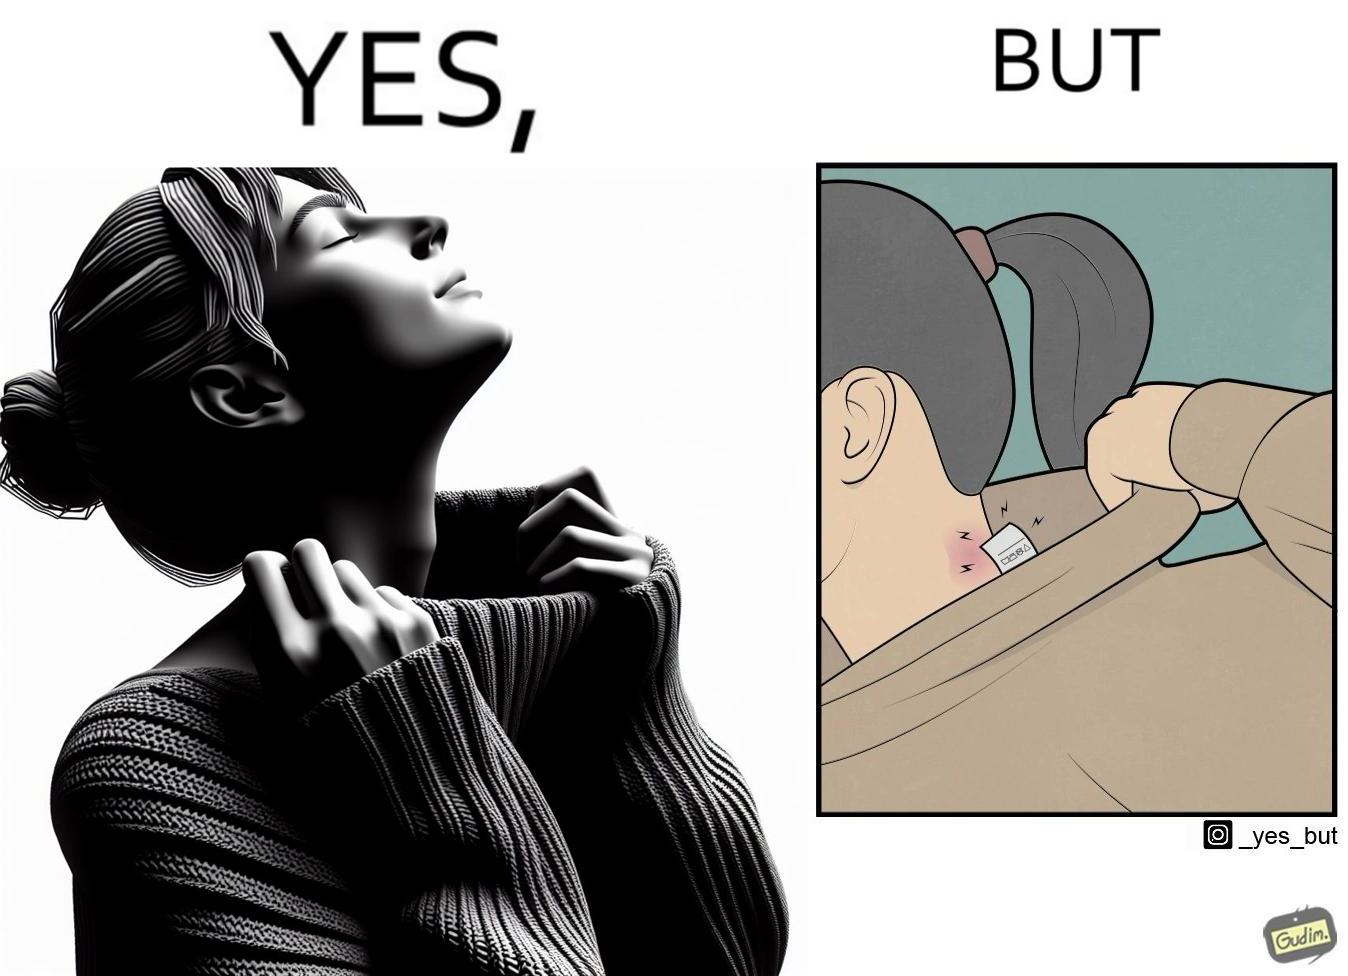Is this image satirical or non-satirical? Yes, this image is satirical. 